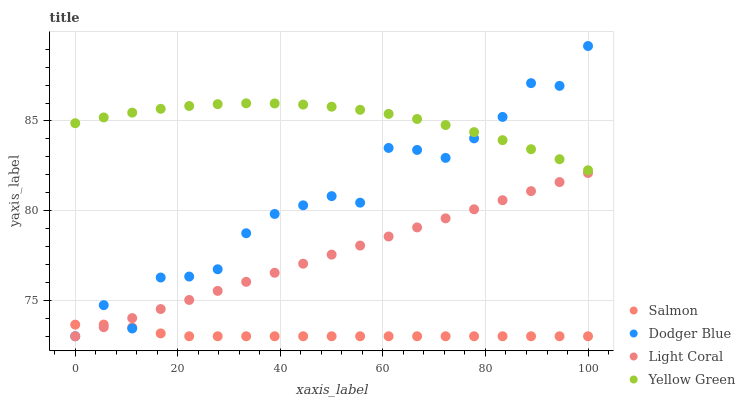Does Salmon have the minimum area under the curve?
Answer yes or no. Yes. Does Yellow Green have the maximum area under the curve?
Answer yes or no. Yes. Does Dodger Blue have the minimum area under the curve?
Answer yes or no. No. Does Dodger Blue have the maximum area under the curve?
Answer yes or no. No. Is Light Coral the smoothest?
Answer yes or no. Yes. Is Dodger Blue the roughest?
Answer yes or no. Yes. Is Salmon the smoothest?
Answer yes or no. No. Is Salmon the roughest?
Answer yes or no. No. Does Light Coral have the lowest value?
Answer yes or no. Yes. Does Yellow Green have the lowest value?
Answer yes or no. No. Does Dodger Blue have the highest value?
Answer yes or no. Yes. Does Salmon have the highest value?
Answer yes or no. No. Is Light Coral less than Yellow Green?
Answer yes or no. Yes. Is Yellow Green greater than Light Coral?
Answer yes or no. Yes. Does Salmon intersect Light Coral?
Answer yes or no. Yes. Is Salmon less than Light Coral?
Answer yes or no. No. Is Salmon greater than Light Coral?
Answer yes or no. No. Does Light Coral intersect Yellow Green?
Answer yes or no. No. 